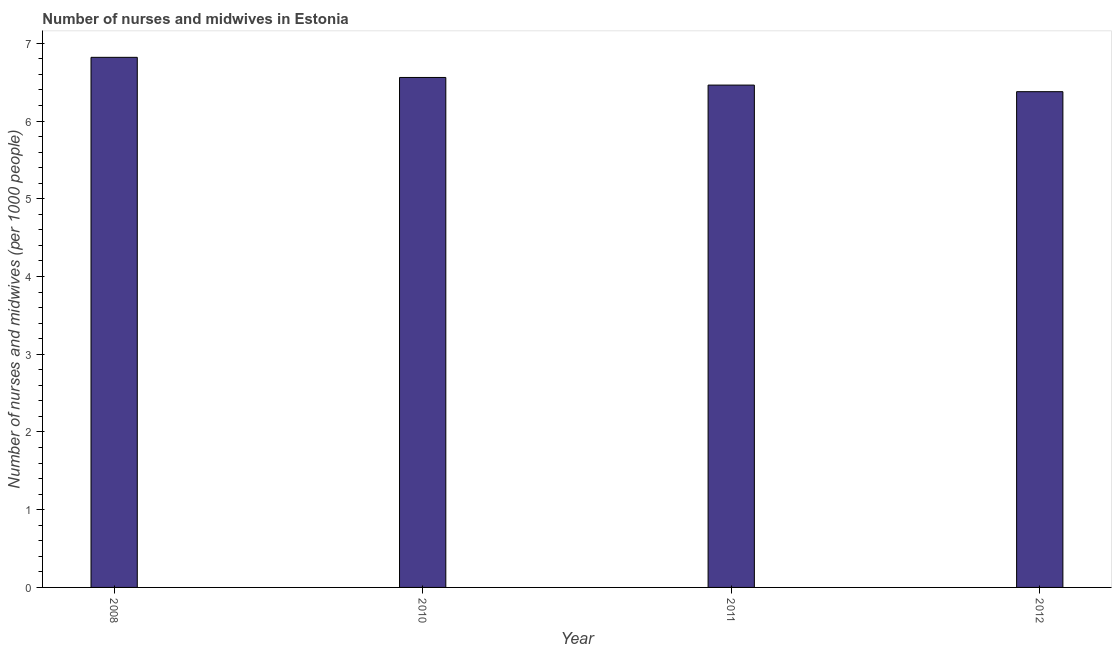What is the title of the graph?
Provide a short and direct response. Number of nurses and midwives in Estonia. What is the label or title of the X-axis?
Your response must be concise. Year. What is the label or title of the Y-axis?
Offer a terse response. Number of nurses and midwives (per 1000 people). What is the number of nurses and midwives in 2011?
Your response must be concise. 6.46. Across all years, what is the maximum number of nurses and midwives?
Make the answer very short. 6.82. Across all years, what is the minimum number of nurses and midwives?
Provide a short and direct response. 6.38. In which year was the number of nurses and midwives maximum?
Ensure brevity in your answer.  2008. In which year was the number of nurses and midwives minimum?
Ensure brevity in your answer.  2012. What is the sum of the number of nurses and midwives?
Give a very brief answer. 26.22. What is the difference between the number of nurses and midwives in 2008 and 2011?
Offer a terse response. 0.36. What is the average number of nurses and midwives per year?
Your response must be concise. 6.56. What is the median number of nurses and midwives?
Make the answer very short. 6.51. In how many years, is the number of nurses and midwives greater than 0.8 ?
Provide a succinct answer. 4. Do a majority of the years between 2008 and 2011 (inclusive) have number of nurses and midwives greater than 3.2 ?
Provide a succinct answer. Yes. What is the ratio of the number of nurses and midwives in 2008 to that in 2012?
Your answer should be very brief. 1.07. Is the difference between the number of nurses and midwives in 2008 and 2010 greater than the difference between any two years?
Give a very brief answer. No. What is the difference between the highest and the second highest number of nurses and midwives?
Give a very brief answer. 0.26. Is the sum of the number of nurses and midwives in 2008 and 2010 greater than the maximum number of nurses and midwives across all years?
Make the answer very short. Yes. What is the difference between the highest and the lowest number of nurses and midwives?
Provide a succinct answer. 0.44. In how many years, is the number of nurses and midwives greater than the average number of nurses and midwives taken over all years?
Ensure brevity in your answer.  2. How many bars are there?
Offer a terse response. 4. What is the Number of nurses and midwives (per 1000 people) in 2008?
Provide a succinct answer. 6.82. What is the Number of nurses and midwives (per 1000 people) of 2010?
Offer a terse response. 6.56. What is the Number of nurses and midwives (per 1000 people) of 2011?
Offer a very short reply. 6.46. What is the Number of nurses and midwives (per 1000 people) of 2012?
Your answer should be very brief. 6.38. What is the difference between the Number of nurses and midwives (per 1000 people) in 2008 and 2010?
Your response must be concise. 0.26. What is the difference between the Number of nurses and midwives (per 1000 people) in 2008 and 2011?
Offer a very short reply. 0.36. What is the difference between the Number of nurses and midwives (per 1000 people) in 2008 and 2012?
Ensure brevity in your answer.  0.44. What is the difference between the Number of nurses and midwives (per 1000 people) in 2010 and 2011?
Give a very brief answer. 0.1. What is the difference between the Number of nurses and midwives (per 1000 people) in 2010 and 2012?
Your answer should be very brief. 0.18. What is the difference between the Number of nurses and midwives (per 1000 people) in 2011 and 2012?
Keep it short and to the point. 0.09. What is the ratio of the Number of nurses and midwives (per 1000 people) in 2008 to that in 2010?
Offer a terse response. 1.04. What is the ratio of the Number of nurses and midwives (per 1000 people) in 2008 to that in 2011?
Offer a terse response. 1.05. What is the ratio of the Number of nurses and midwives (per 1000 people) in 2008 to that in 2012?
Provide a succinct answer. 1.07. 